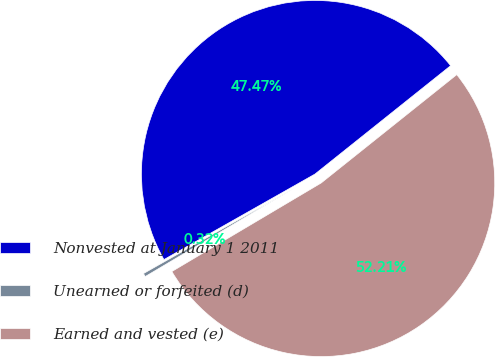Convert chart to OTSL. <chart><loc_0><loc_0><loc_500><loc_500><pie_chart><fcel>Nonvested at January 1 2011<fcel>Unearned or forfeited (d)<fcel>Earned and vested (e)<nl><fcel>47.47%<fcel>0.32%<fcel>52.21%<nl></chart> 